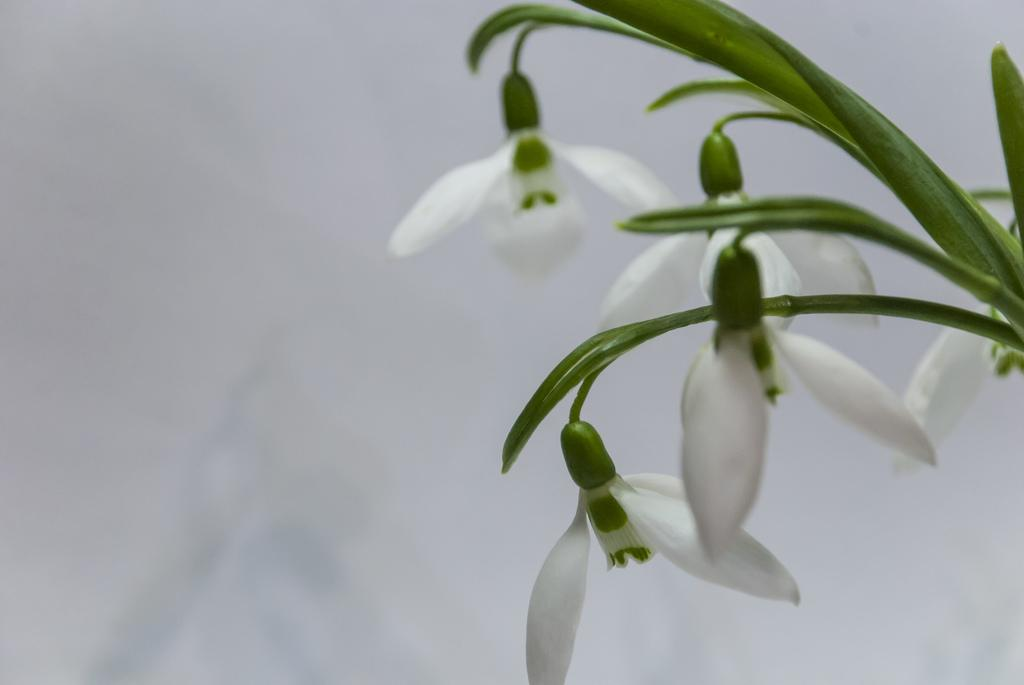What color are the flowers on the plant in the image? The flowers on the plant are white. Can you describe the plant in the image? The image only shows white color flowers on the plant. How is the image quality at the back? The image is blurry at the back. What type of fly is sitting on the governor's shoulder in the image? There is no fly or governor present in the image; it only features a plant with white flowers. 